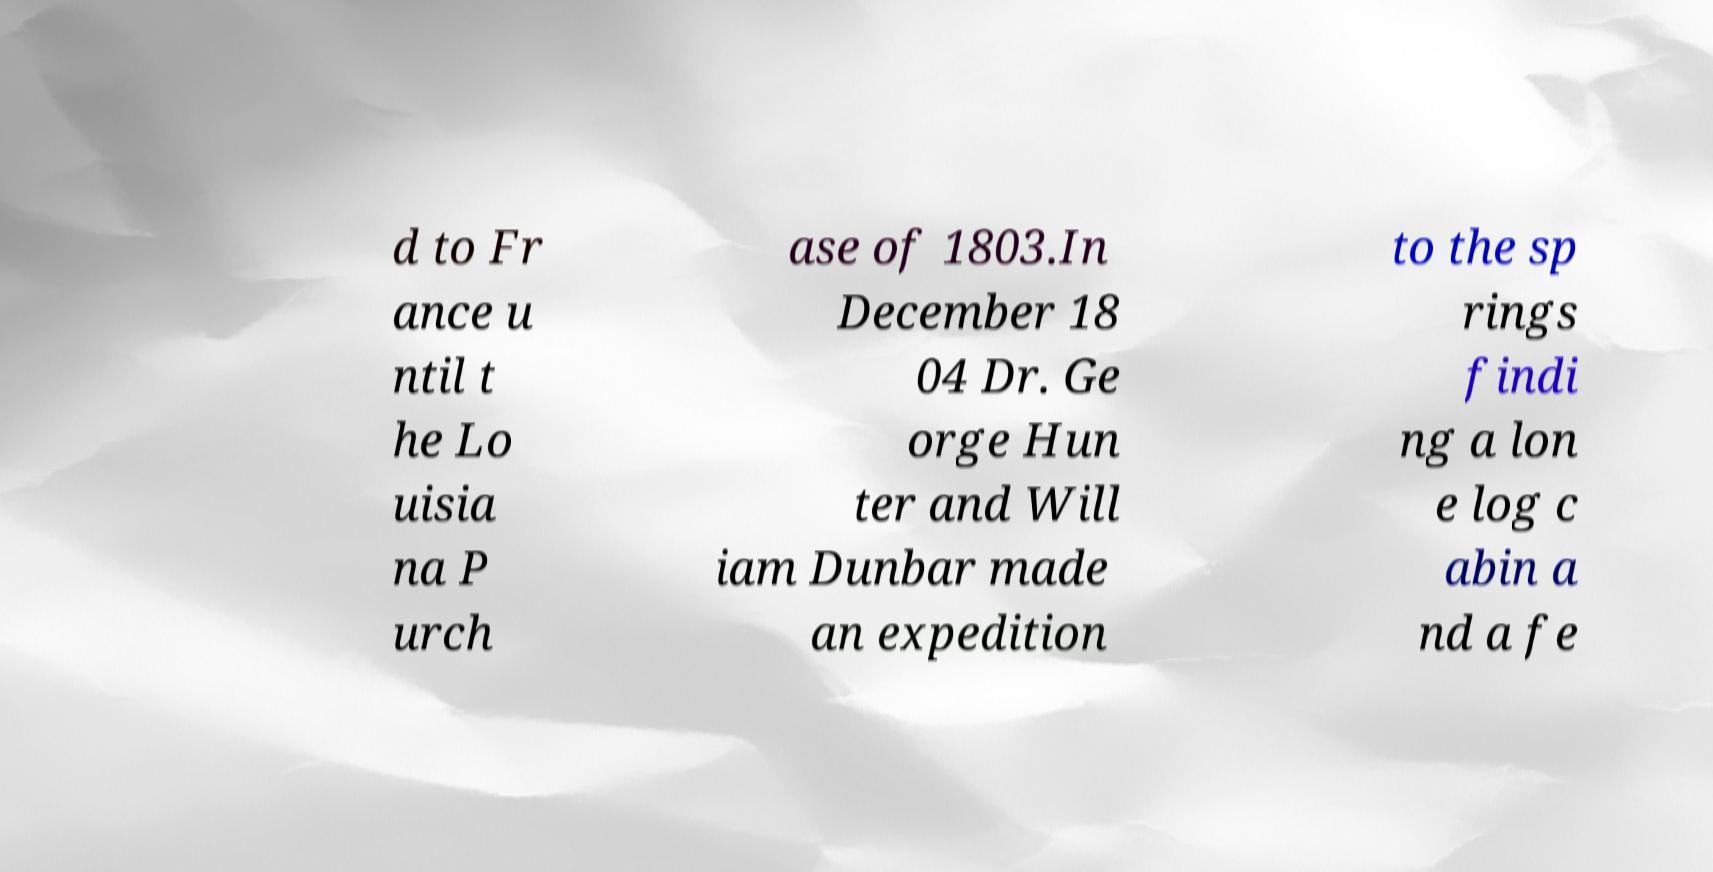For documentation purposes, I need the text within this image transcribed. Could you provide that? d to Fr ance u ntil t he Lo uisia na P urch ase of 1803.In December 18 04 Dr. Ge orge Hun ter and Will iam Dunbar made an expedition to the sp rings findi ng a lon e log c abin a nd a fe 